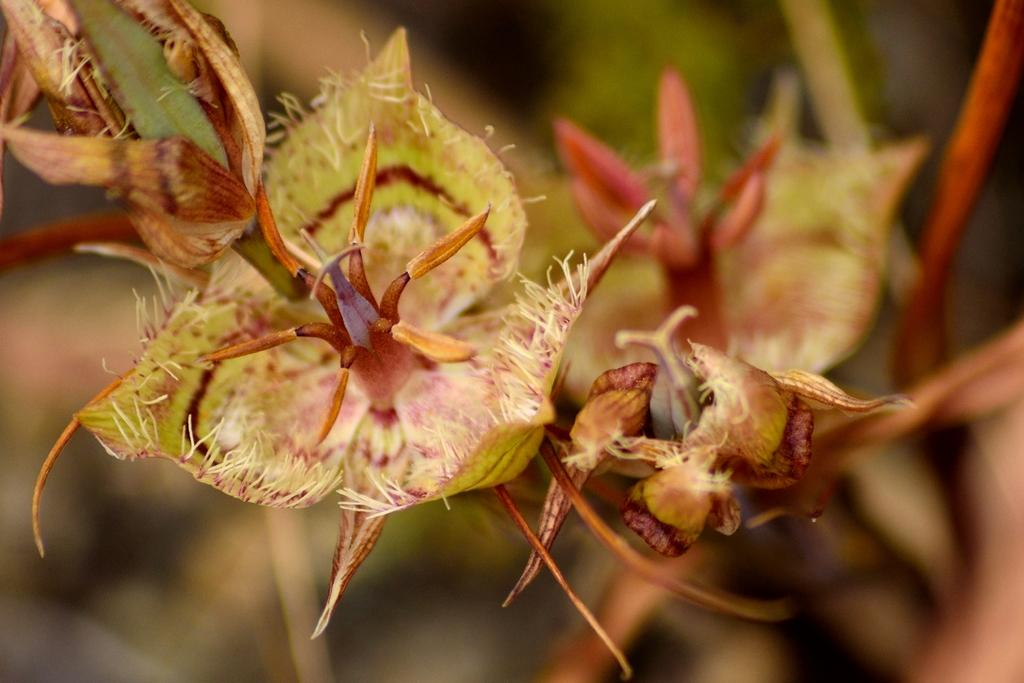What is the main subject of the image? The main subject of the image is many flowers. Are there any flowers in the image that are not fully bloomed? Yes, there are buds in the image. How would you describe the background of the image? The background of the image appears blurry. What type of copper material can be seen on the moon in the image? There is no copper material or moon present in the image; it features many flowers and buds with a blurry background. How does the cough affect the flowers in the image? There is no cough present in the image, and therefore it cannot affect the flowers. 